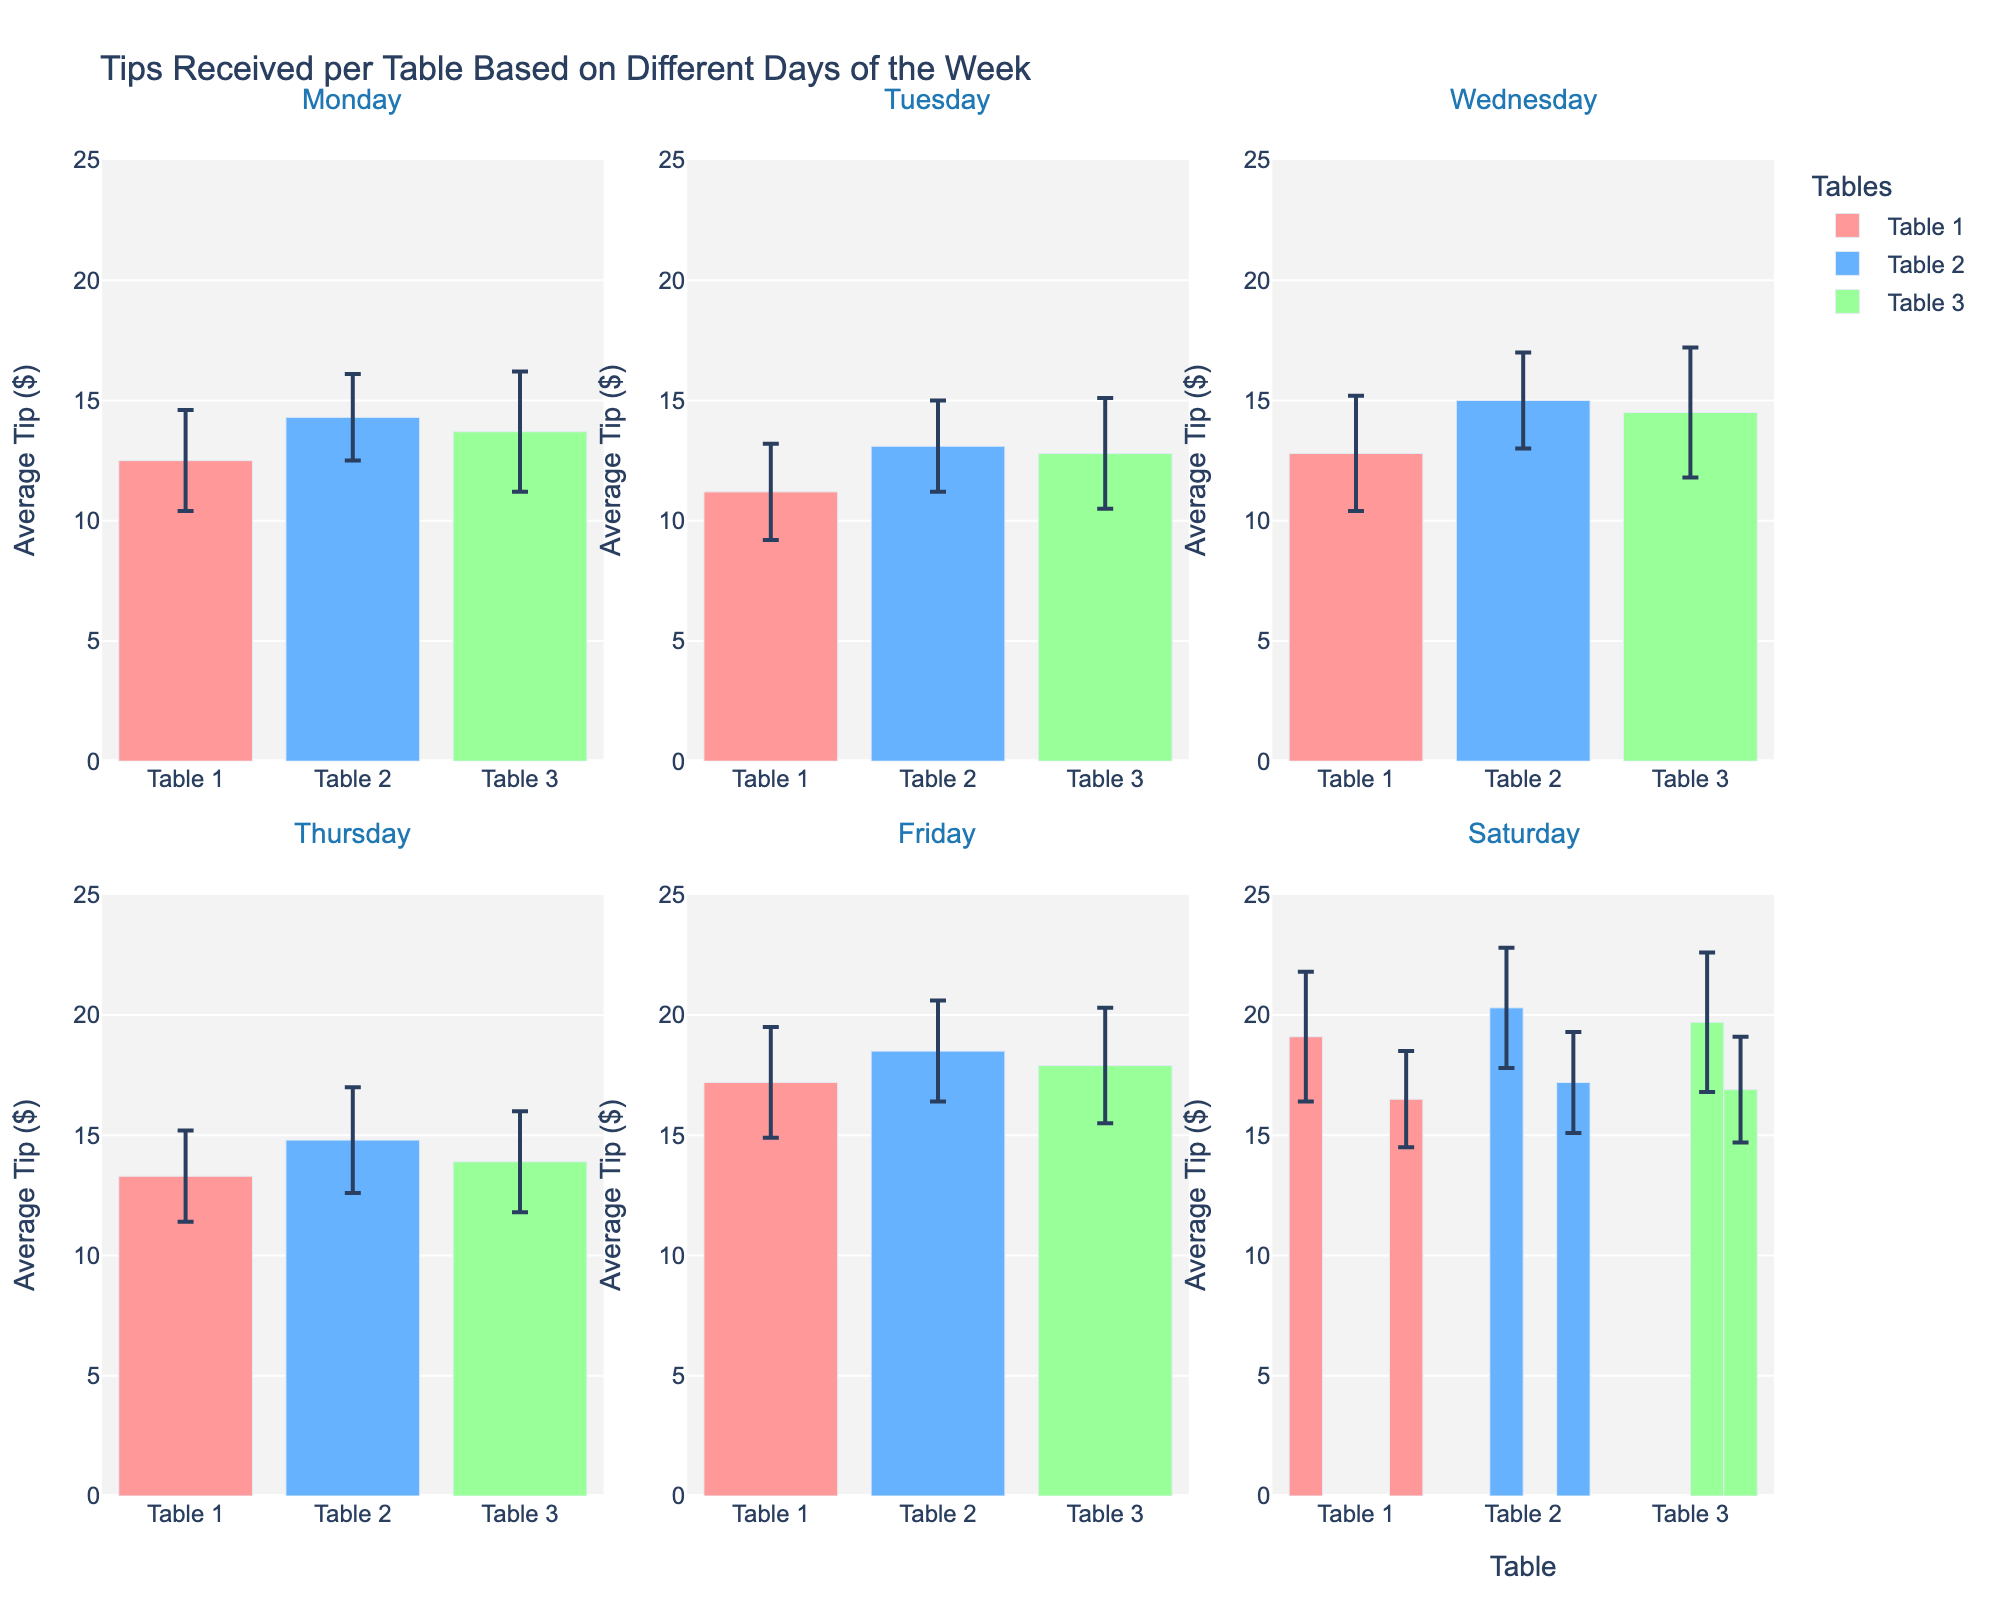What is the title of the figure? The title is written at the top of the figure and describes what the figure is about.
Answer: "Tips Received per Table Based on Different Days of the Week" What does the x-axis represent in each subplot? The x-axis labels the different tables (e.g., Table 1, Table 2, Table 3) shown in the subplot.
Answer: Tables Which day shows the highest average tip for Table 1? Look at the subplot for each day and identify the bar for Table 1 with the highest average tip.
Answer: Saturday How does the average tip for Table 3 on Friday compare to Table 2 on Wednesday? Check the average tips for Table 3 on Friday and Table 2 on Wednesday in their respective subplots and compare their heights.
Answer: Higher What is the range of average tips shown on the y-axis? The y-axis ranges are displayed on the left side of the figure, indicating the limits for average tips.
Answer: 0 to 25 On which days does Table 2 have an average tip within one standard deviation above or below $14? Look at the error bars for Table 2 in each day's subplot to see if the average tip (± 1 SD) includes $14.
Answer: Monday, Thursday Which table has the most consistent tipping pattern across the week (i.e., least standard deviation)? Identify the table whose error bars (representing standard deviation) are the shortest across all subplots from Monday to Sunday.
Answer: Table 2 Are the tips for Table 3 more variable on Monday or Tuesday? Compare the standard deviation error bars of Table 3 in the Monday and Tuesday subplots.
Answer: Monday What pattern can be observed about the tips received from Friday to Sunday? Observe the trend in average tips and standard deviations for each table from the subplots for Friday, Saturday, and Sunday.
Answer: Increasing tips Is there any table that consistently received the highest average tips throughout the week? Compare the heights of bars across all days for each table to see if any one table generally received higher tips than others.
Answer: No 